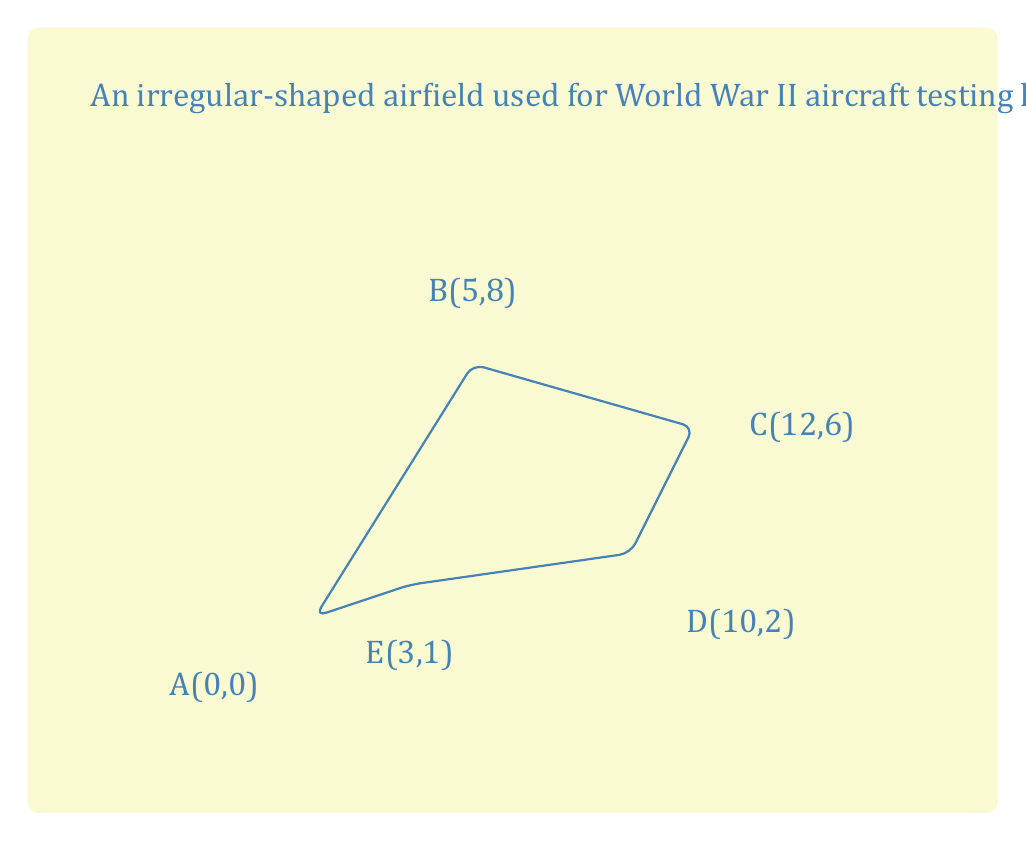Provide a solution to this math problem. To find the area of this irregular airfield, we can use the Shoelace formula (also known as the surveyor's formula). This method is particularly useful for calculating the area of an irregular polygon given its vertices.

The Shoelace formula is:

$$Area = \frac{1}{2}|(x_1y_2 + x_2y_3 + ... + x_ny_1) - (y_1x_2 + y_2x_3 + ... + y_nx_1)|$$

Where $(x_i, y_i)$ are the coordinates of the $i$-th vertex.

Let's apply this formula to our airfield:

1) First, list the coordinates in order:
   (0, 0), (5, 8), (12, 6), (10, 2), (3, 1)

2) Calculate the first part of the formula:
   $$(0 \cdot 8) + (5 \cdot 6) + (12 \cdot 2) + (10 \cdot 1) + (3 \cdot 0) = 0 + 30 + 24 + 10 + 0 = 64$$

3) Calculate the second part of the formula:
   $$(0 \cdot 5) + (8 \cdot 12) + (6 \cdot 10) + (2 \cdot 3) + (1 \cdot 0) = 0 + 96 + 60 + 6 + 0 = 162$$

4) Subtract the second part from the first part:
   $$64 - 162 = -98$$

5) Take the absolute value and divide by 2:
   $$Area = \frac{1}{2}|-98| = \frac{98}{2} = 49$$

Therefore, the area of the airfield is 49 square units.
Answer: 49 square units 